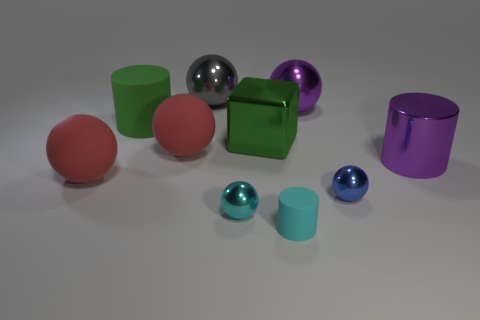Subtract all purple metal cylinders. How many cylinders are left? 2 Subtract all cyan cylinders. How many cylinders are left? 2 Subtract all green cubes. How many red balls are left? 2 Subtract all cubes. How many objects are left? 9 Subtract 2 cylinders. How many cylinders are left? 1 Subtract all brown blocks. Subtract all gray cylinders. How many blocks are left? 1 Subtract all large gray spheres. Subtract all small gray metallic cylinders. How many objects are left? 9 Add 2 blue metal spheres. How many blue metal spheres are left? 3 Add 3 big green matte cylinders. How many big green matte cylinders exist? 4 Subtract 0 yellow cylinders. How many objects are left? 10 